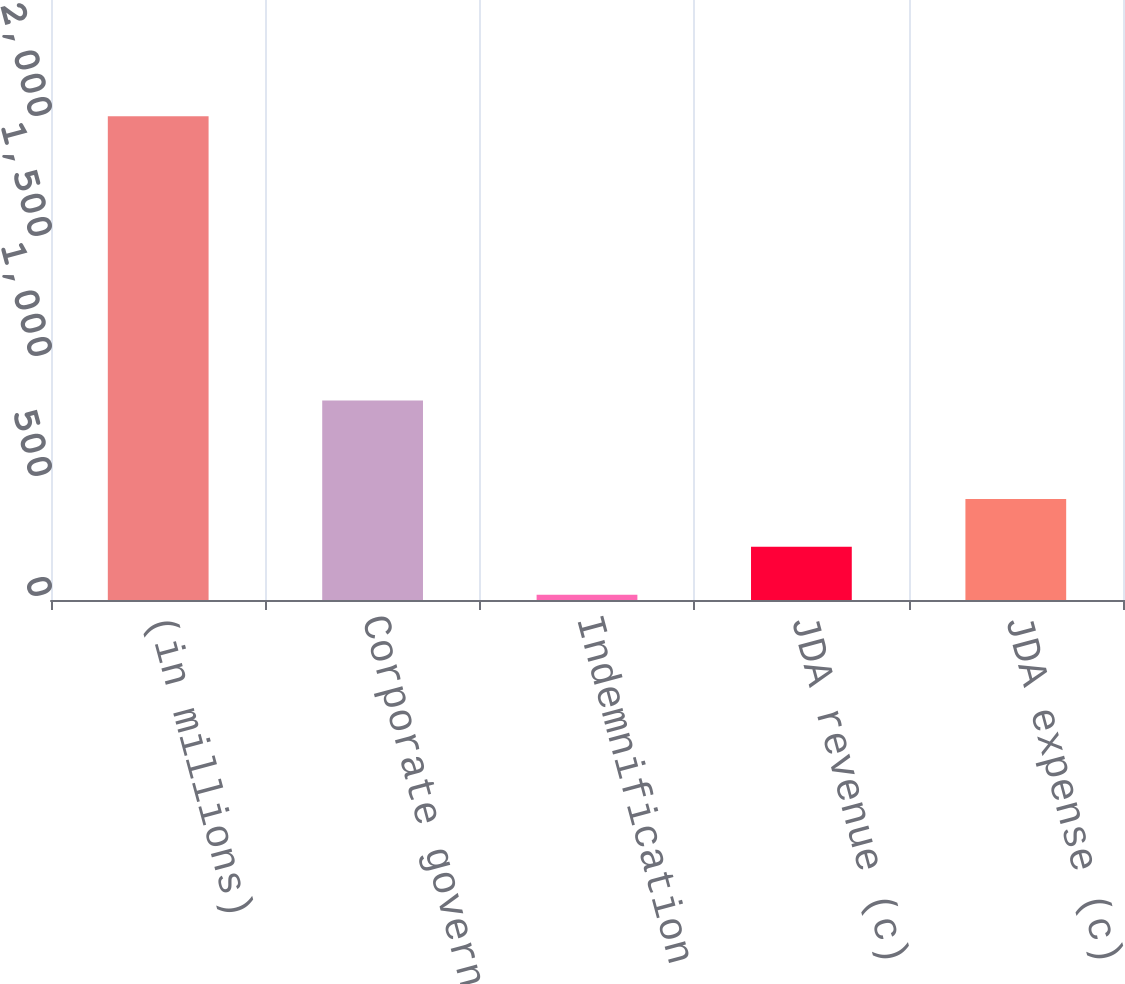Convert chart. <chart><loc_0><loc_0><loc_500><loc_500><bar_chart><fcel>(in millions)<fcel>Corporate governance and<fcel>Indemnification coverages (b)<fcel>JDA revenue (c)<fcel>JDA expense (c)<nl><fcel>2016<fcel>831<fcel>22<fcel>221.4<fcel>420.8<nl></chart> 